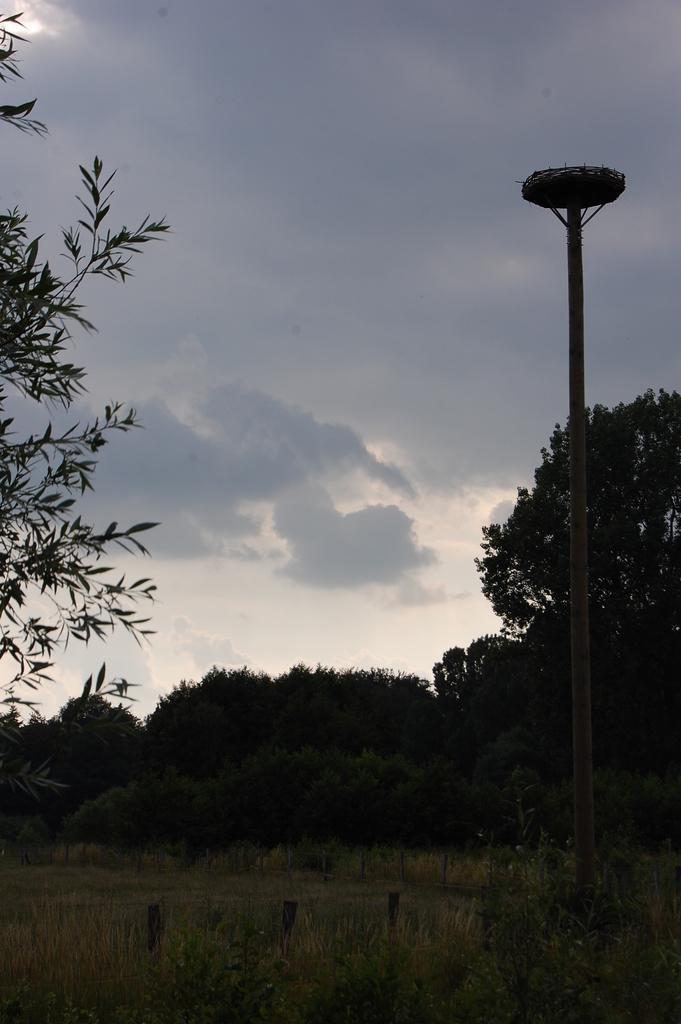How would you summarize this image in a sentence or two? Here in this picture we can see a ground, which is fully covered with grass over there and we can see trees and plants present all over there and on the right side we can see a pole present and we can see clouds in the sky over there. 